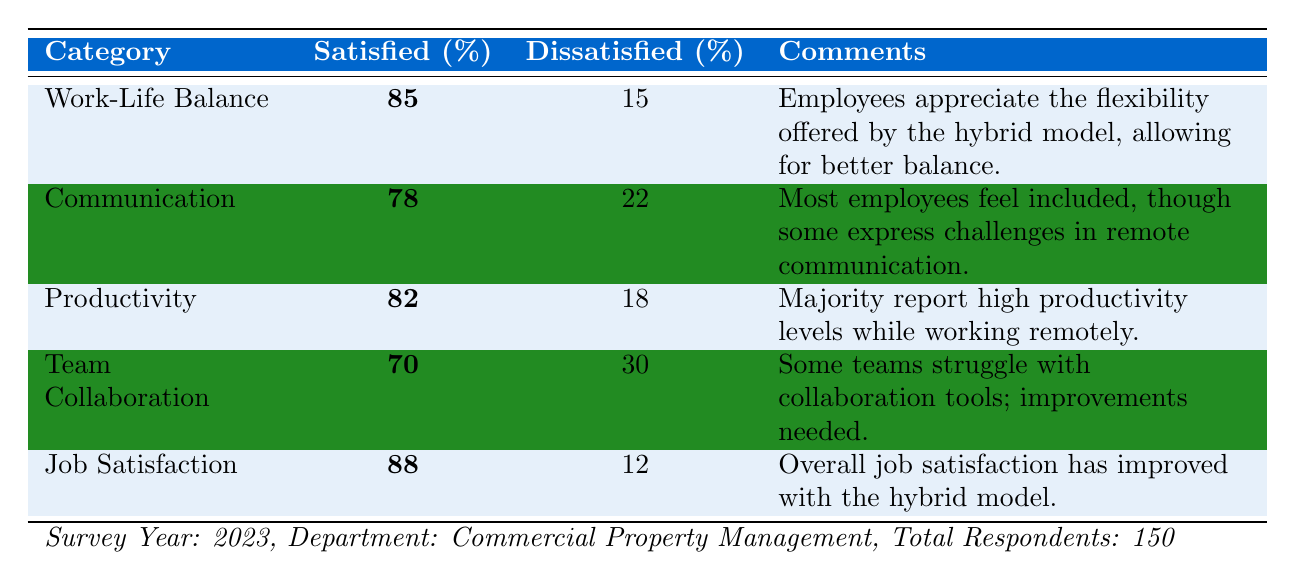What percentage of employees are satisfied with Work-Life Balance? The table shows the percentage satisfied with Work-Life Balance as **85%**.
Answer: 85% What is the percentage of employees dissatisfied with Team Collaboration? The table indicates that **30%** of employees are dissatisfied with Team Collaboration.
Answer: 30% How many employees reported high productivity levels according to the survey? Since the total respondents are **150**, and **82%** are satisfied with productivity, the number satisfied is 150 * 0.82 = **123** employees.
Answer: 123 Is the percentage satisfied with Job Satisfaction higher than that for Communication? The percentage satisfied with Job Satisfaction is **88%**, and for Communication, it is **78%**. Since 88% > 78%, the statement is true.
Answer: Yes What is the difference between the percentage of satisfied employees for Job Satisfaction and Team Collaboration? Job Satisfaction is at **88%**, and Team Collaboration is **70%**. The difference is 88% - 70% = **18%**.
Answer: 18% How many more employees are satisfied with Productivity compared to Team Collaboration? For Productivity, **82%** are satisfied and for Team Collaboration, **70%** are satisfied. The difference is 82% - 70% = **12%**. To find the number, 150 * 0.12 = **18** more employees.
Answer: 18 What are the suggested changes for areas marked as high priority? The table lists "Collaboration Tools" and "Feedback Mechanisms" as high priority. The changes suggested are "Implement more intuitive collaboration platforms" and "Establish regular feedback loops to gauge employee sentiments."
Answer: Collaboration Tools and Feedback Mechanisms Are employee satisfaction levels for Communication below the average satisfaction for all key areas? The total satisfied percentages include: 85 (Work-Life Balance) + 78 (Communication) + 82 (Productivity) + 70 (Team Collaboration) + 88 (Job Satisfaction) = 403. The average is 403 / 5 = **80.6%**. Since Communication is at 78%, it is below the average.
Answer: Yes What percentage of employees are satisfied with both Work-Life Balance and Job Satisfaction? The satisfaction percentages are **85%** for Work-Life Balance and **88%** for Job Satisfaction. The combined percentage of satisfied employees would involve looking at how many are satisfied in both categories, which isn't straightforwardly calculable from the data provided. However, we can say they are both above 80%.
Answer: Not directly answerable from data What steps can be taken to improve Team Collaboration based on employee feedback? Based on the table, it suggests that improvements in collaboration tools are needed, therefore implementing more intuitive collaboration platforms would be a key step to enhance Team Collaboration based on feedback.
Answer: Implement more intuitive collaboration platforms 